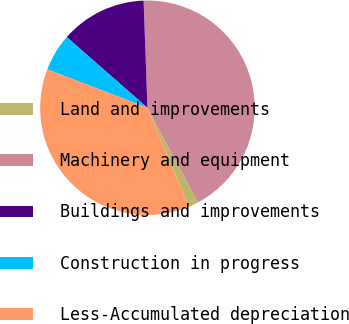<chart> <loc_0><loc_0><loc_500><loc_500><pie_chart><fcel>Land and improvements<fcel>Machinery and equipment<fcel>Buildings and improvements<fcel>Construction in progress<fcel>Less-Accumulated depreciation<nl><fcel>1.49%<fcel>42.77%<fcel>12.98%<fcel>5.62%<fcel>37.13%<nl></chart> 